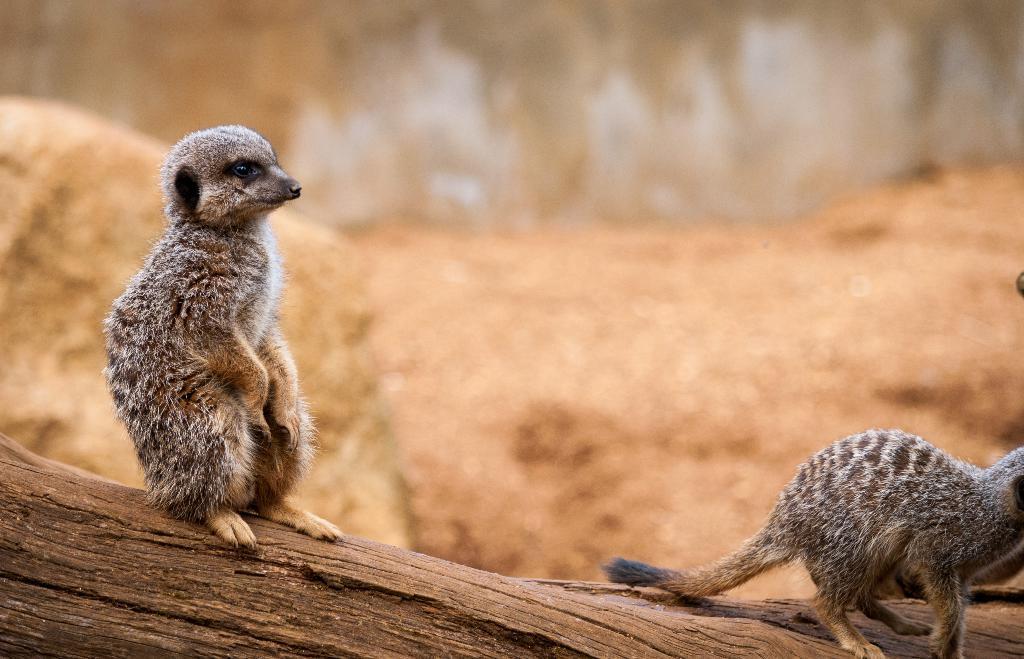Can you describe this image briefly? To the bottom of the image there is a tree truck. On the trunk there are two meerkat. And there is a blur black background. 